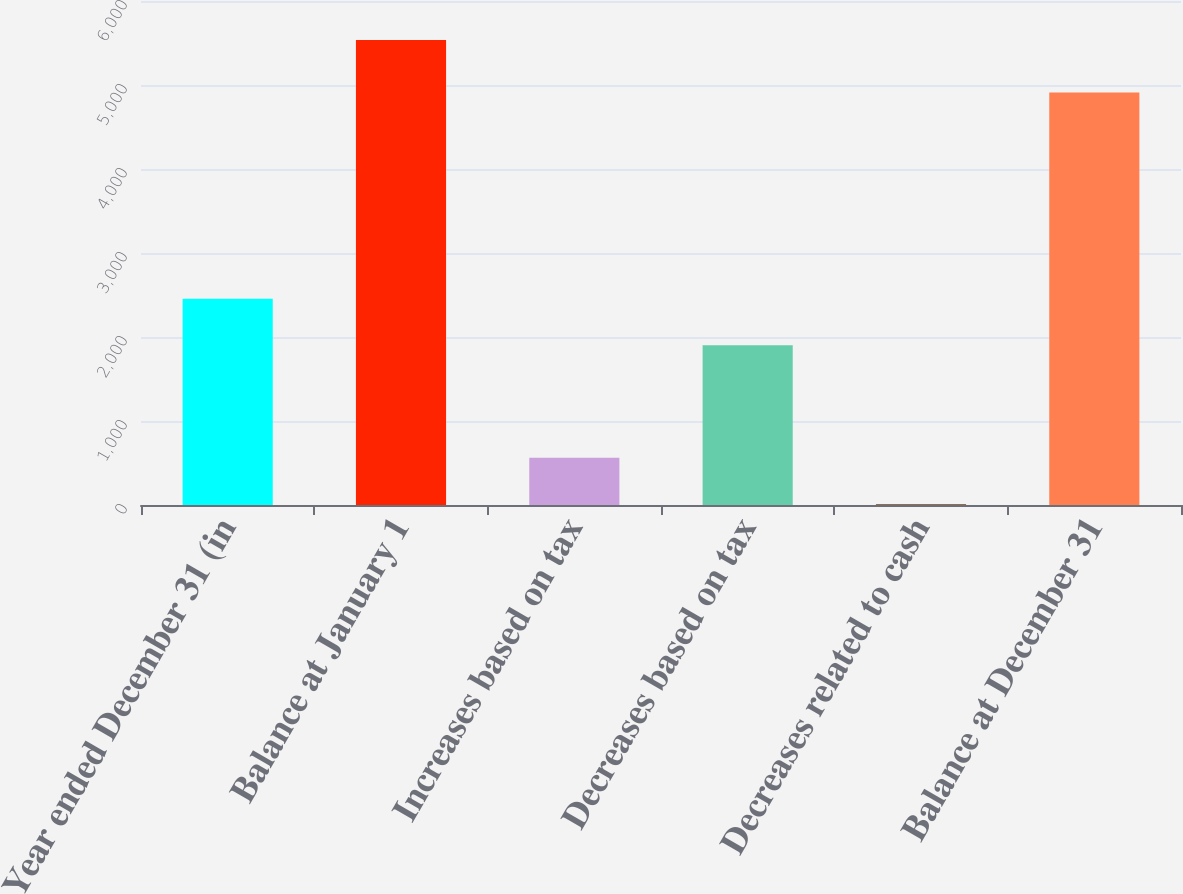<chart> <loc_0><loc_0><loc_500><loc_500><bar_chart><fcel>Year ended December 31 (in<fcel>Balance at January 1<fcel>Increases based on tax<fcel>Decreases based on tax<fcel>Decreases related to cash<fcel>Balance at December 31<nl><fcel>2454.6<fcel>5535<fcel>561.6<fcel>1902<fcel>9<fcel>4911<nl></chart> 